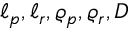<formula> <loc_0><loc_0><loc_500><loc_500>\ell _ { p } , \ell _ { r } , \varrho _ { p } , \varrho _ { r } , D</formula> 